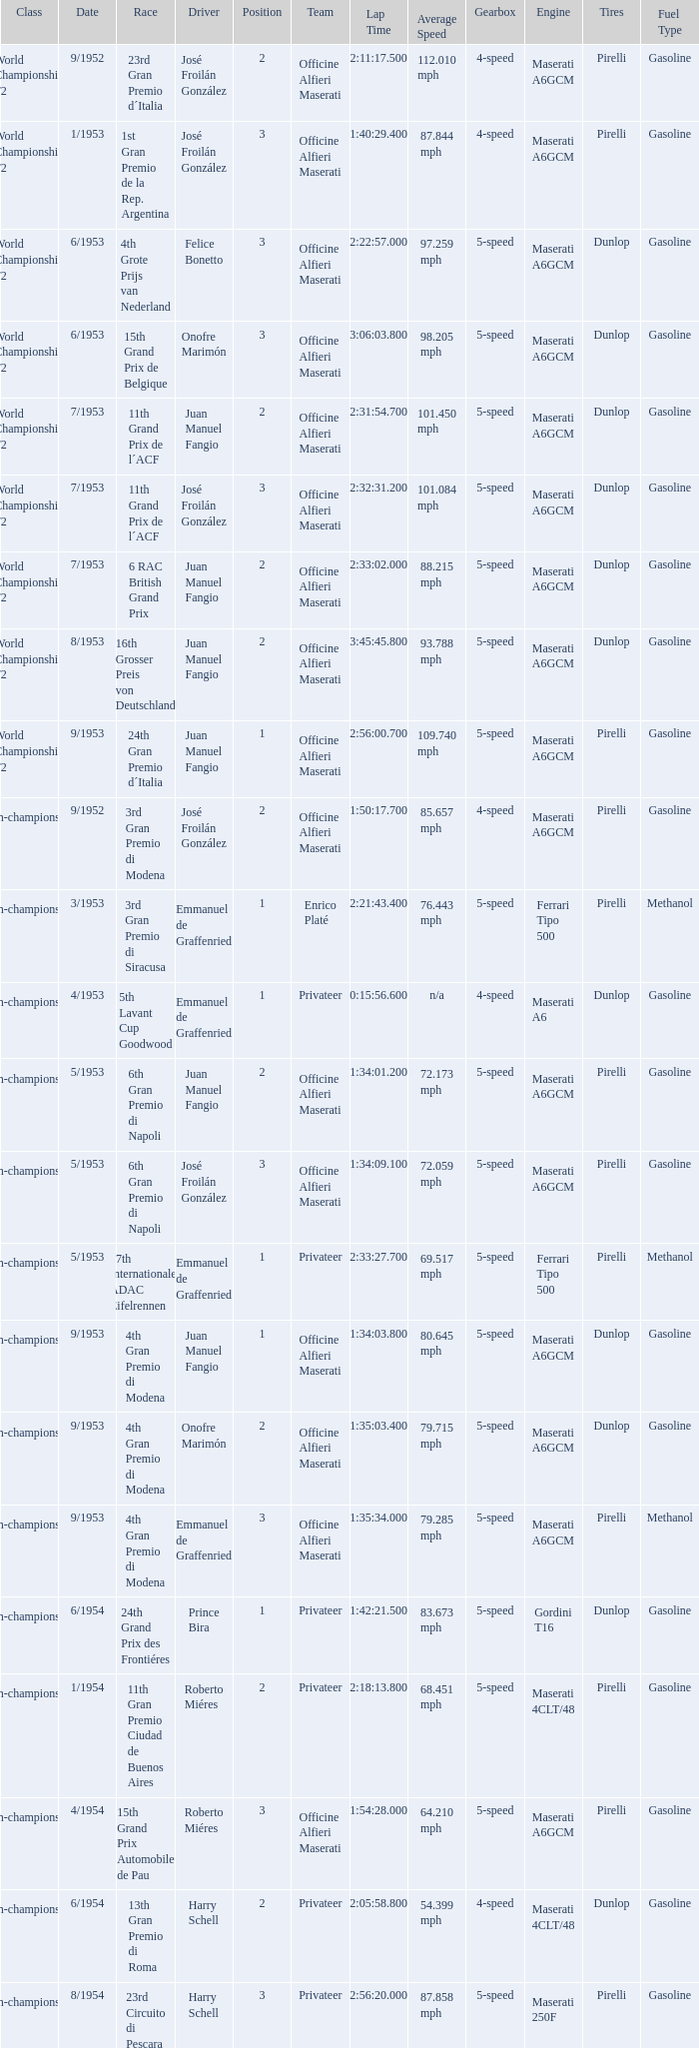What date has the class of non-championship f2 as well as a driver name josé froilán gonzález that has a position larger than 2? 5/1953. 